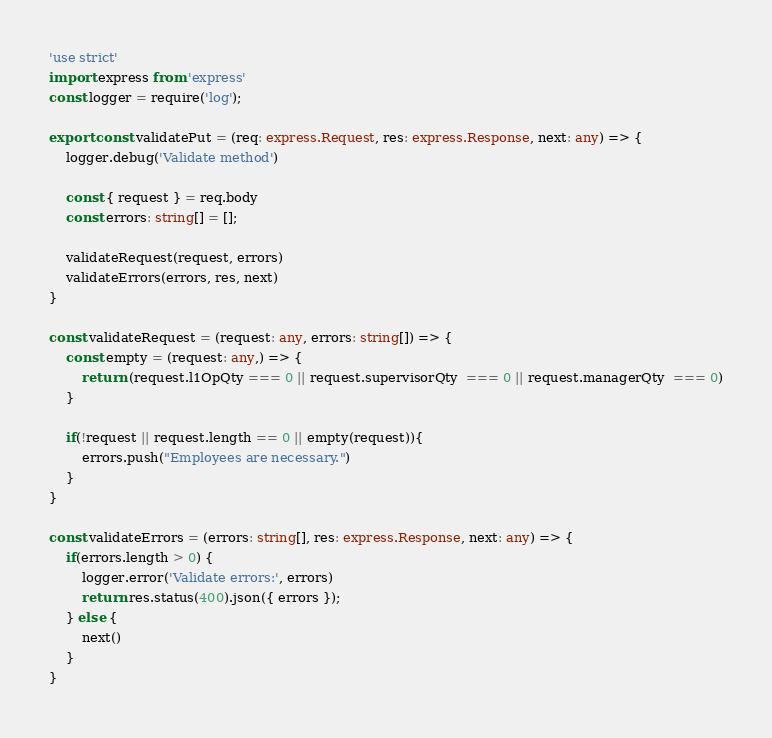Convert code to text. <code><loc_0><loc_0><loc_500><loc_500><_TypeScript_>'use strict'
import express from 'express'
const logger = require('log');

export const validatePut = (req: express.Request, res: express.Response, next: any) => {
	logger.debug('Validate method')

	const { request } = req.body
	const errors: string[] = [];

	validateRequest(request, errors)
	validateErrors(errors, res, next)
}

const validateRequest = (request: any, errors: string[]) => {
	const empty = (request: any,) => {
		return (request.l1OpQty === 0 || request.supervisorQty  === 0 || request.managerQty  === 0)
	}

	if(!request || request.length == 0 || empty(request)){
		errors.push("Employees are necessary.")
	}
}

const validateErrors = (errors: string[], res: express.Response, next: any) => {
	if(errors.length > 0) {
		logger.error('Validate errors:', errors)
		return res.status(400).json({ errors });
	} else {
		next()
	}
}</code> 